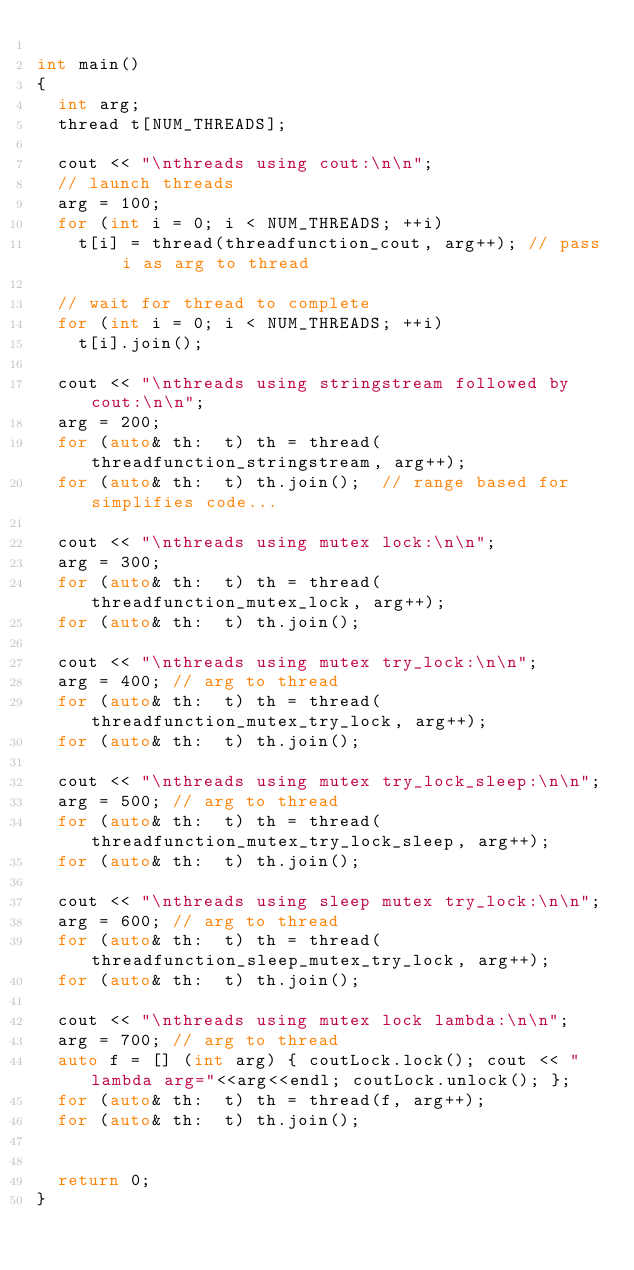<code> <loc_0><loc_0><loc_500><loc_500><_C++_>
int main() 
{
  int arg;
  thread t[NUM_THREADS];

  cout << "\nthreads using cout:\n\n";
  // launch threads
  arg = 100;
  for (int i = 0; i < NUM_THREADS; ++i)
    t[i] = thread(threadfunction_cout, arg++); // pass i as arg to thread

  // wait for thread to complete
  for (int i = 0; i < NUM_THREADS; ++i)
    t[i].join();

  cout << "\nthreads using stringstream followed by cout:\n\n";
  arg = 200;
  for (auto& th:  t) th = thread(threadfunction_stringstream, arg++);
  for (auto& th:  t) th.join();  // range based for simplifies code...

  cout << "\nthreads using mutex lock:\n\n";
  arg = 300;
  for (auto& th:  t) th = thread(threadfunction_mutex_lock, arg++);
  for (auto& th:  t) th.join();

  cout << "\nthreads using mutex try_lock:\n\n";
  arg = 400; // arg to thread 
  for (auto& th:  t) th = thread(threadfunction_mutex_try_lock, arg++);
  for (auto& th:  t) th.join();

  cout << "\nthreads using mutex try_lock_sleep:\n\n";
  arg = 500; // arg to thread 
  for (auto& th:  t) th = thread(threadfunction_mutex_try_lock_sleep, arg++);
  for (auto& th:  t) th.join();

  cout << "\nthreads using sleep mutex try_lock:\n\n";
  arg = 600; // arg to thread 
  for (auto& th:  t) th = thread(threadfunction_sleep_mutex_try_lock, arg++);
  for (auto& th:  t) th.join();

  cout << "\nthreads using mutex lock lambda:\n\n";
  arg = 700; // arg to thread 
  auto f = [] (int arg) { coutLock.lock(); cout << "lambda arg="<<arg<<endl; coutLock.unlock(); };
  for (auto& th:  t) th = thread(f, arg++);
  for (auto& th:  t) th.join();


  return 0;
}
</code> 